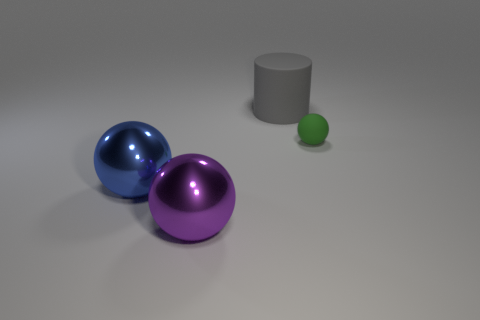Are there any big shiny things in front of the large shiny thing that is in front of the big shiny thing behind the purple thing?
Provide a short and direct response. No. Is the big purple metallic thing the same shape as the gray rubber thing?
Your response must be concise. No. Are there fewer purple metal balls to the left of the big purple object than tiny purple spheres?
Keep it short and to the point. No. What is the color of the rubber thing that is on the right side of the large object that is behind the sphere that is on the right side of the large cylinder?
Keep it short and to the point. Green. What number of shiny objects are either cylinders or large blue spheres?
Offer a very short reply. 1. Does the gray cylinder have the same size as the purple metallic object?
Make the answer very short. Yes. Are there fewer large matte cylinders that are in front of the green ball than small rubber things that are behind the purple shiny sphere?
Provide a succinct answer. Yes. Are there any other things that are the same size as the blue metallic thing?
Provide a short and direct response. Yes. The purple metallic ball is what size?
Your response must be concise. Large. How many tiny things are either brown metallic things or green things?
Ensure brevity in your answer.  1. 